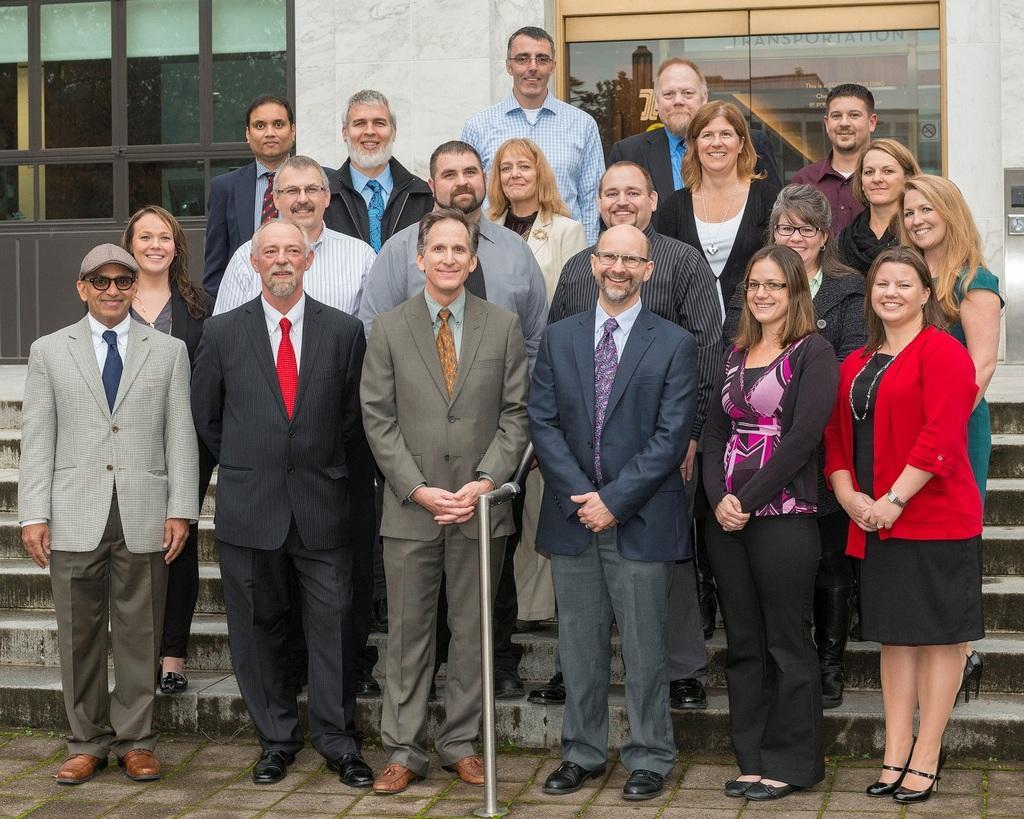Can you describe this image briefly? Here we can see group of people and they are smiling. In the background we can see a wall and glasses. On the glass we can see the reflection of a building. 